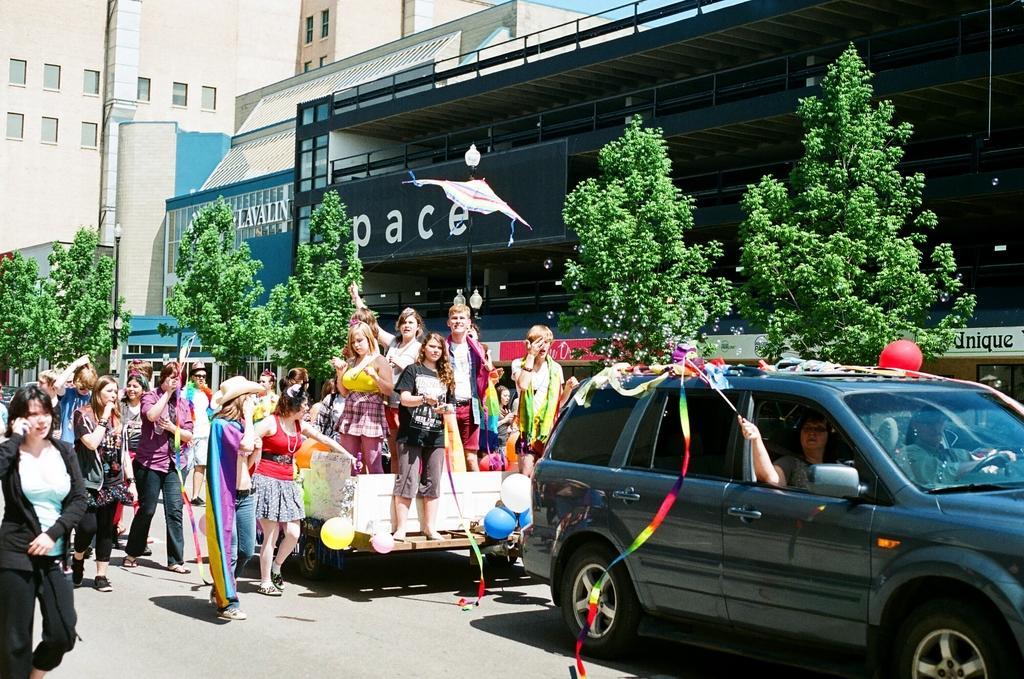Describe this image in one or two sentences. There are building and plants plants in front of them and there is a vehicle where few girls are standing on it and travelling along with car. 